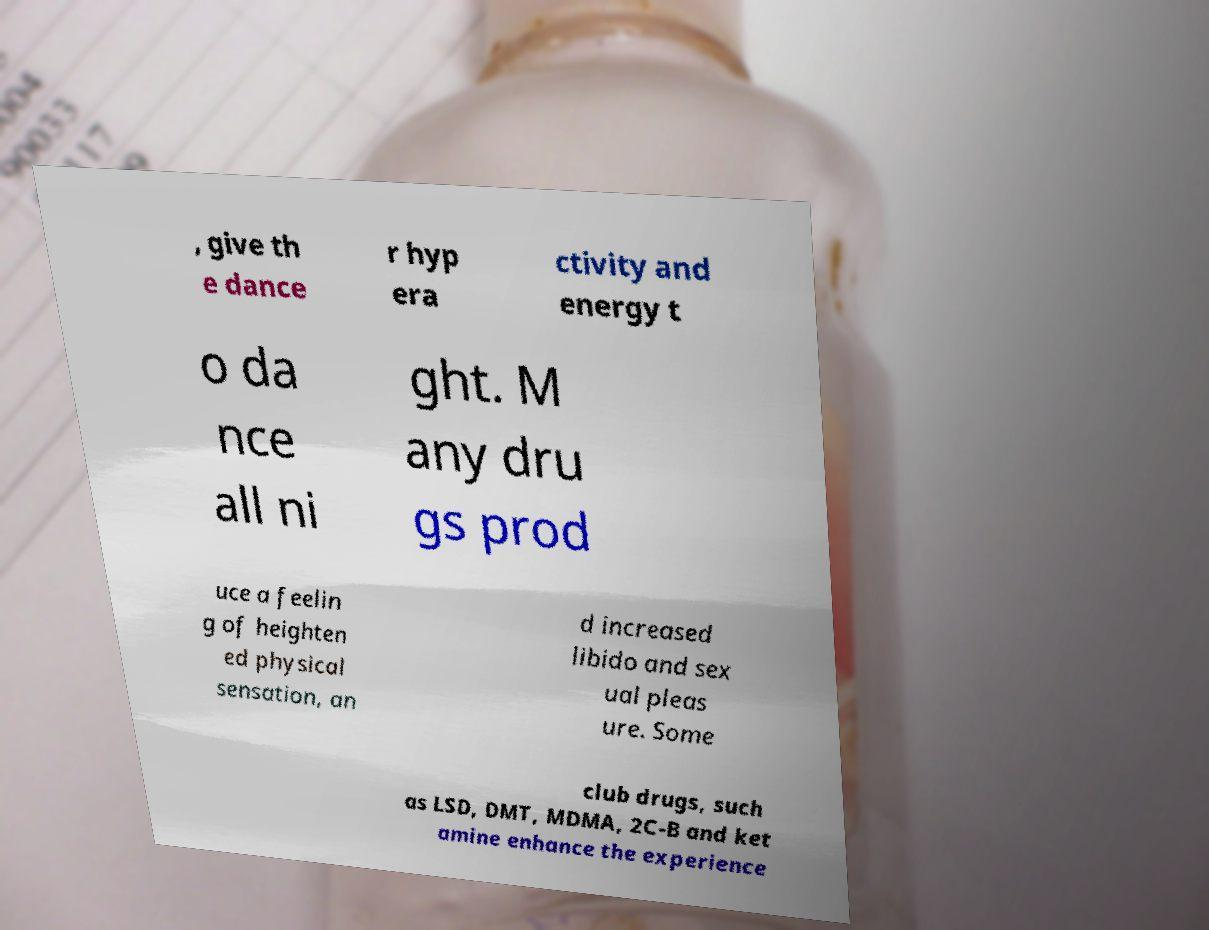There's text embedded in this image that I need extracted. Can you transcribe it verbatim? , give th e dance r hyp era ctivity and energy t o da nce all ni ght. M any dru gs prod uce a feelin g of heighten ed physical sensation, an d increased libido and sex ual pleas ure. Some club drugs, such as LSD, DMT, MDMA, 2C-B and ket amine enhance the experience 